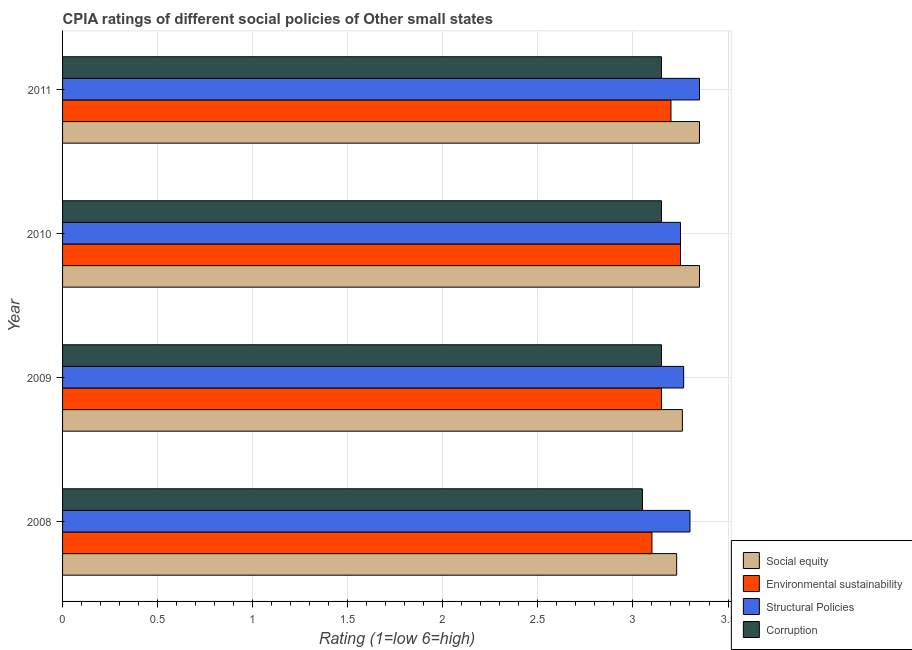Are the number of bars per tick equal to the number of legend labels?
Your answer should be compact. Yes. Are the number of bars on each tick of the Y-axis equal?
Offer a terse response. Yes. How many bars are there on the 1st tick from the top?
Keep it short and to the point. 4. How many bars are there on the 3rd tick from the bottom?
Ensure brevity in your answer.  4. What is the label of the 4th group of bars from the top?
Give a very brief answer. 2008. In how many cases, is the number of bars for a given year not equal to the number of legend labels?
Give a very brief answer. 0. What is the cpia rating of environmental sustainability in 2009?
Ensure brevity in your answer.  3.15. Across all years, what is the maximum cpia rating of structural policies?
Your answer should be compact. 3.35. Across all years, what is the minimum cpia rating of social equity?
Your answer should be compact. 3.23. In which year was the cpia rating of social equity maximum?
Your response must be concise. 2010. In which year was the cpia rating of social equity minimum?
Ensure brevity in your answer.  2008. What is the total cpia rating of social equity in the graph?
Make the answer very short. 13.19. What is the difference between the cpia rating of structural policies in 2008 and that in 2010?
Provide a short and direct response. 0.05. What is the difference between the cpia rating of environmental sustainability in 2010 and the cpia rating of structural policies in 2008?
Ensure brevity in your answer.  -0.05. What is the average cpia rating of environmental sustainability per year?
Your answer should be very brief. 3.17. In how many years, is the cpia rating of structural policies greater than 0.9 ?
Offer a terse response. 4. What is the difference between the highest and the lowest cpia rating of corruption?
Provide a short and direct response. 0.1. In how many years, is the cpia rating of corruption greater than the average cpia rating of corruption taken over all years?
Offer a very short reply. 3. Is it the case that in every year, the sum of the cpia rating of environmental sustainability and cpia rating of corruption is greater than the sum of cpia rating of structural policies and cpia rating of social equity?
Provide a succinct answer. No. What does the 3rd bar from the top in 2008 represents?
Provide a succinct answer. Environmental sustainability. What does the 1st bar from the bottom in 2008 represents?
Your answer should be compact. Social equity. Is it the case that in every year, the sum of the cpia rating of social equity and cpia rating of environmental sustainability is greater than the cpia rating of structural policies?
Offer a very short reply. Yes. How many years are there in the graph?
Keep it short and to the point. 4. Does the graph contain any zero values?
Provide a short and direct response. No. Does the graph contain grids?
Your answer should be compact. Yes. Where does the legend appear in the graph?
Your answer should be very brief. Bottom right. How many legend labels are there?
Keep it short and to the point. 4. What is the title of the graph?
Offer a very short reply. CPIA ratings of different social policies of Other small states. What is the Rating (1=low 6=high) of Social equity in 2008?
Ensure brevity in your answer.  3.23. What is the Rating (1=low 6=high) of Corruption in 2008?
Make the answer very short. 3.05. What is the Rating (1=low 6=high) of Social equity in 2009?
Ensure brevity in your answer.  3.26. What is the Rating (1=low 6=high) of Environmental sustainability in 2009?
Offer a very short reply. 3.15. What is the Rating (1=low 6=high) in Structural Policies in 2009?
Offer a very short reply. 3.27. What is the Rating (1=low 6=high) of Corruption in 2009?
Offer a terse response. 3.15. What is the Rating (1=low 6=high) in Social equity in 2010?
Your answer should be very brief. 3.35. What is the Rating (1=low 6=high) in Corruption in 2010?
Offer a very short reply. 3.15. What is the Rating (1=low 6=high) of Social equity in 2011?
Provide a succinct answer. 3.35. What is the Rating (1=low 6=high) of Environmental sustainability in 2011?
Your response must be concise. 3.2. What is the Rating (1=low 6=high) in Structural Policies in 2011?
Your answer should be compact. 3.35. What is the Rating (1=low 6=high) in Corruption in 2011?
Give a very brief answer. 3.15. Across all years, what is the maximum Rating (1=low 6=high) in Social equity?
Make the answer very short. 3.35. Across all years, what is the maximum Rating (1=low 6=high) in Environmental sustainability?
Provide a succinct answer. 3.25. Across all years, what is the maximum Rating (1=low 6=high) in Structural Policies?
Your answer should be compact. 3.35. Across all years, what is the maximum Rating (1=low 6=high) of Corruption?
Your answer should be very brief. 3.15. Across all years, what is the minimum Rating (1=low 6=high) in Social equity?
Offer a very short reply. 3.23. Across all years, what is the minimum Rating (1=low 6=high) in Environmental sustainability?
Make the answer very short. 3.1. Across all years, what is the minimum Rating (1=low 6=high) of Corruption?
Your response must be concise. 3.05. What is the total Rating (1=low 6=high) in Social equity in the graph?
Provide a succinct answer. 13.19. What is the total Rating (1=low 6=high) of Structural Policies in the graph?
Offer a terse response. 13.17. What is the difference between the Rating (1=low 6=high) in Social equity in 2008 and that in 2009?
Provide a short and direct response. -0.03. What is the difference between the Rating (1=low 6=high) in Environmental sustainability in 2008 and that in 2009?
Give a very brief answer. -0.05. What is the difference between the Rating (1=low 6=high) in Structural Policies in 2008 and that in 2009?
Offer a terse response. 0.03. What is the difference between the Rating (1=low 6=high) of Social equity in 2008 and that in 2010?
Keep it short and to the point. -0.12. What is the difference between the Rating (1=low 6=high) in Environmental sustainability in 2008 and that in 2010?
Ensure brevity in your answer.  -0.15. What is the difference between the Rating (1=low 6=high) in Structural Policies in 2008 and that in 2010?
Your answer should be compact. 0.05. What is the difference between the Rating (1=low 6=high) in Corruption in 2008 and that in 2010?
Provide a succinct answer. -0.1. What is the difference between the Rating (1=low 6=high) of Social equity in 2008 and that in 2011?
Keep it short and to the point. -0.12. What is the difference between the Rating (1=low 6=high) in Environmental sustainability in 2008 and that in 2011?
Your answer should be compact. -0.1. What is the difference between the Rating (1=low 6=high) of Corruption in 2008 and that in 2011?
Give a very brief answer. -0.1. What is the difference between the Rating (1=low 6=high) in Social equity in 2009 and that in 2010?
Offer a terse response. -0.09. What is the difference between the Rating (1=low 6=high) of Structural Policies in 2009 and that in 2010?
Your response must be concise. 0.02. What is the difference between the Rating (1=low 6=high) in Social equity in 2009 and that in 2011?
Give a very brief answer. -0.09. What is the difference between the Rating (1=low 6=high) in Structural Policies in 2009 and that in 2011?
Keep it short and to the point. -0.08. What is the difference between the Rating (1=low 6=high) of Corruption in 2009 and that in 2011?
Your response must be concise. 0. What is the difference between the Rating (1=low 6=high) in Social equity in 2010 and that in 2011?
Provide a succinct answer. 0. What is the difference between the Rating (1=low 6=high) of Structural Policies in 2010 and that in 2011?
Ensure brevity in your answer.  -0.1. What is the difference between the Rating (1=low 6=high) in Social equity in 2008 and the Rating (1=low 6=high) in Structural Policies in 2009?
Keep it short and to the point. -0.04. What is the difference between the Rating (1=low 6=high) of Social equity in 2008 and the Rating (1=low 6=high) of Corruption in 2009?
Ensure brevity in your answer.  0.08. What is the difference between the Rating (1=low 6=high) in Structural Policies in 2008 and the Rating (1=low 6=high) in Corruption in 2009?
Your response must be concise. 0.15. What is the difference between the Rating (1=low 6=high) of Social equity in 2008 and the Rating (1=low 6=high) of Environmental sustainability in 2010?
Ensure brevity in your answer.  -0.02. What is the difference between the Rating (1=low 6=high) of Social equity in 2008 and the Rating (1=low 6=high) of Structural Policies in 2010?
Offer a very short reply. -0.02. What is the difference between the Rating (1=low 6=high) in Environmental sustainability in 2008 and the Rating (1=low 6=high) in Structural Policies in 2010?
Provide a succinct answer. -0.15. What is the difference between the Rating (1=low 6=high) in Environmental sustainability in 2008 and the Rating (1=low 6=high) in Corruption in 2010?
Offer a terse response. -0.05. What is the difference between the Rating (1=low 6=high) in Social equity in 2008 and the Rating (1=low 6=high) in Structural Policies in 2011?
Provide a short and direct response. -0.12. What is the difference between the Rating (1=low 6=high) in Environmental sustainability in 2008 and the Rating (1=low 6=high) in Corruption in 2011?
Offer a terse response. -0.05. What is the difference between the Rating (1=low 6=high) of Social equity in 2009 and the Rating (1=low 6=high) of Structural Policies in 2010?
Keep it short and to the point. 0.01. What is the difference between the Rating (1=low 6=high) of Social equity in 2009 and the Rating (1=low 6=high) of Corruption in 2010?
Give a very brief answer. 0.11. What is the difference between the Rating (1=low 6=high) of Environmental sustainability in 2009 and the Rating (1=low 6=high) of Structural Policies in 2010?
Provide a short and direct response. -0.1. What is the difference between the Rating (1=low 6=high) of Environmental sustainability in 2009 and the Rating (1=low 6=high) of Corruption in 2010?
Provide a short and direct response. 0. What is the difference between the Rating (1=low 6=high) in Structural Policies in 2009 and the Rating (1=low 6=high) in Corruption in 2010?
Your answer should be very brief. 0.12. What is the difference between the Rating (1=low 6=high) of Social equity in 2009 and the Rating (1=low 6=high) of Structural Policies in 2011?
Your answer should be compact. -0.09. What is the difference between the Rating (1=low 6=high) in Social equity in 2009 and the Rating (1=low 6=high) in Corruption in 2011?
Provide a succinct answer. 0.11. What is the difference between the Rating (1=low 6=high) of Environmental sustainability in 2009 and the Rating (1=low 6=high) of Structural Policies in 2011?
Provide a succinct answer. -0.2. What is the difference between the Rating (1=low 6=high) in Structural Policies in 2009 and the Rating (1=low 6=high) in Corruption in 2011?
Make the answer very short. 0.12. What is the difference between the Rating (1=low 6=high) of Social equity in 2010 and the Rating (1=low 6=high) of Environmental sustainability in 2011?
Make the answer very short. 0.15. What is the difference between the Rating (1=low 6=high) in Social equity in 2010 and the Rating (1=low 6=high) in Structural Policies in 2011?
Offer a very short reply. 0. What is the difference between the Rating (1=low 6=high) in Structural Policies in 2010 and the Rating (1=low 6=high) in Corruption in 2011?
Your response must be concise. 0.1. What is the average Rating (1=low 6=high) of Social equity per year?
Make the answer very short. 3.3. What is the average Rating (1=low 6=high) in Environmental sustainability per year?
Your response must be concise. 3.17. What is the average Rating (1=low 6=high) in Structural Policies per year?
Give a very brief answer. 3.29. What is the average Rating (1=low 6=high) in Corruption per year?
Provide a succinct answer. 3.12. In the year 2008, what is the difference between the Rating (1=low 6=high) in Social equity and Rating (1=low 6=high) in Environmental sustainability?
Provide a short and direct response. 0.13. In the year 2008, what is the difference between the Rating (1=low 6=high) of Social equity and Rating (1=low 6=high) of Structural Policies?
Keep it short and to the point. -0.07. In the year 2008, what is the difference between the Rating (1=low 6=high) in Social equity and Rating (1=low 6=high) in Corruption?
Provide a short and direct response. 0.18. In the year 2008, what is the difference between the Rating (1=low 6=high) of Environmental sustainability and Rating (1=low 6=high) of Corruption?
Ensure brevity in your answer.  0.05. In the year 2008, what is the difference between the Rating (1=low 6=high) of Structural Policies and Rating (1=low 6=high) of Corruption?
Provide a succinct answer. 0.25. In the year 2009, what is the difference between the Rating (1=low 6=high) in Social equity and Rating (1=low 6=high) in Environmental sustainability?
Keep it short and to the point. 0.11. In the year 2009, what is the difference between the Rating (1=low 6=high) in Social equity and Rating (1=low 6=high) in Structural Policies?
Offer a very short reply. -0.01. In the year 2009, what is the difference between the Rating (1=low 6=high) in Social equity and Rating (1=low 6=high) in Corruption?
Provide a short and direct response. 0.11. In the year 2009, what is the difference between the Rating (1=low 6=high) of Environmental sustainability and Rating (1=low 6=high) of Structural Policies?
Your answer should be very brief. -0.12. In the year 2009, what is the difference between the Rating (1=low 6=high) of Structural Policies and Rating (1=low 6=high) of Corruption?
Offer a terse response. 0.12. In the year 2010, what is the difference between the Rating (1=low 6=high) in Social equity and Rating (1=low 6=high) in Environmental sustainability?
Offer a very short reply. 0.1. In the year 2010, what is the difference between the Rating (1=low 6=high) in Environmental sustainability and Rating (1=low 6=high) in Structural Policies?
Your response must be concise. 0. In the year 2010, what is the difference between the Rating (1=low 6=high) in Environmental sustainability and Rating (1=low 6=high) in Corruption?
Keep it short and to the point. 0.1. In the year 2011, what is the difference between the Rating (1=low 6=high) of Social equity and Rating (1=low 6=high) of Environmental sustainability?
Keep it short and to the point. 0.15. In the year 2011, what is the difference between the Rating (1=low 6=high) of Social equity and Rating (1=low 6=high) of Structural Policies?
Your answer should be compact. 0. In the year 2011, what is the difference between the Rating (1=low 6=high) in Environmental sustainability and Rating (1=low 6=high) in Structural Policies?
Keep it short and to the point. -0.15. What is the ratio of the Rating (1=low 6=high) of Environmental sustainability in 2008 to that in 2009?
Provide a short and direct response. 0.98. What is the ratio of the Rating (1=low 6=high) of Structural Policies in 2008 to that in 2009?
Provide a succinct answer. 1.01. What is the ratio of the Rating (1=low 6=high) in Corruption in 2008 to that in 2009?
Your answer should be very brief. 0.97. What is the ratio of the Rating (1=low 6=high) of Social equity in 2008 to that in 2010?
Your answer should be very brief. 0.96. What is the ratio of the Rating (1=low 6=high) of Environmental sustainability in 2008 to that in 2010?
Your response must be concise. 0.95. What is the ratio of the Rating (1=low 6=high) in Structural Policies in 2008 to that in 2010?
Provide a short and direct response. 1.02. What is the ratio of the Rating (1=low 6=high) in Corruption in 2008 to that in 2010?
Provide a short and direct response. 0.97. What is the ratio of the Rating (1=low 6=high) of Social equity in 2008 to that in 2011?
Your answer should be very brief. 0.96. What is the ratio of the Rating (1=low 6=high) in Environmental sustainability in 2008 to that in 2011?
Your answer should be very brief. 0.97. What is the ratio of the Rating (1=low 6=high) of Structural Policies in 2008 to that in 2011?
Your answer should be compact. 0.99. What is the ratio of the Rating (1=low 6=high) of Corruption in 2008 to that in 2011?
Give a very brief answer. 0.97. What is the ratio of the Rating (1=low 6=high) of Social equity in 2009 to that in 2010?
Your answer should be compact. 0.97. What is the ratio of the Rating (1=low 6=high) in Environmental sustainability in 2009 to that in 2010?
Give a very brief answer. 0.97. What is the ratio of the Rating (1=low 6=high) of Structural Policies in 2009 to that in 2010?
Give a very brief answer. 1.01. What is the ratio of the Rating (1=low 6=high) in Corruption in 2009 to that in 2010?
Ensure brevity in your answer.  1. What is the ratio of the Rating (1=low 6=high) in Social equity in 2009 to that in 2011?
Your response must be concise. 0.97. What is the ratio of the Rating (1=low 6=high) in Environmental sustainability in 2009 to that in 2011?
Your answer should be very brief. 0.98. What is the ratio of the Rating (1=low 6=high) of Structural Policies in 2009 to that in 2011?
Your answer should be very brief. 0.98. What is the ratio of the Rating (1=low 6=high) of Social equity in 2010 to that in 2011?
Offer a terse response. 1. What is the ratio of the Rating (1=low 6=high) of Environmental sustainability in 2010 to that in 2011?
Your response must be concise. 1.02. What is the ratio of the Rating (1=low 6=high) in Structural Policies in 2010 to that in 2011?
Your answer should be compact. 0.97. What is the difference between the highest and the lowest Rating (1=low 6=high) of Social equity?
Provide a succinct answer. 0.12. What is the difference between the highest and the lowest Rating (1=low 6=high) of Structural Policies?
Ensure brevity in your answer.  0.1. 